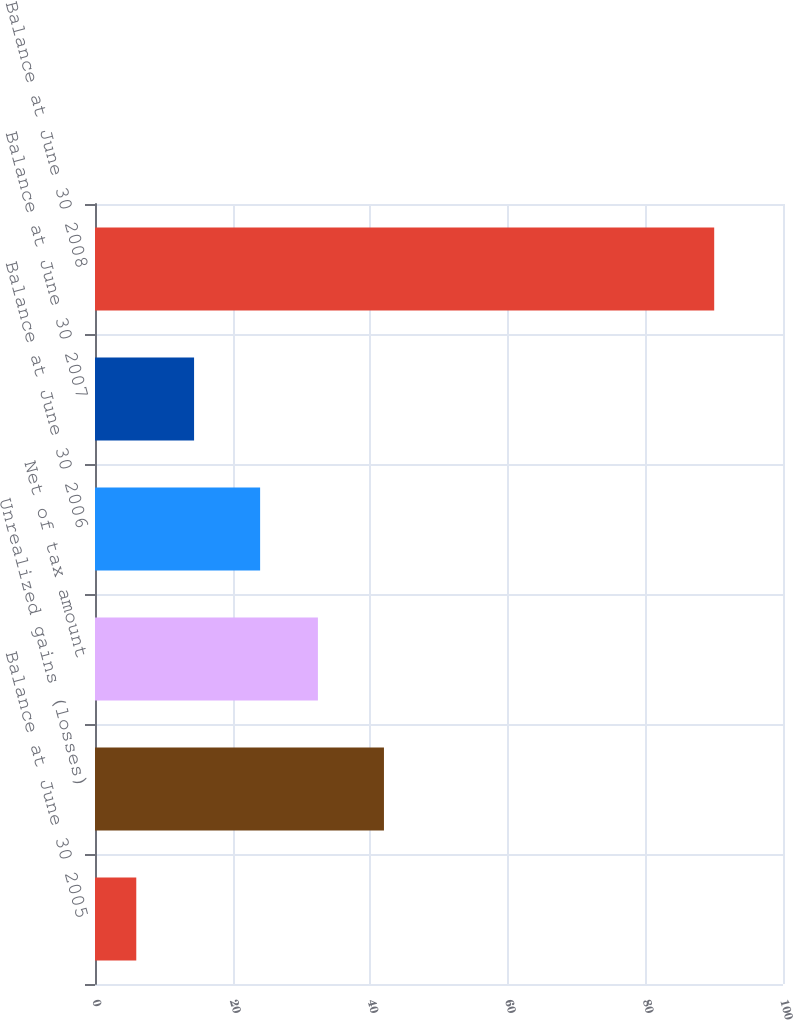<chart> <loc_0><loc_0><loc_500><loc_500><bar_chart><fcel>Balance at June 30 2005<fcel>Unrealized gains (losses)<fcel>Net of tax amount<fcel>Balance at June 30 2006<fcel>Balance at June 30 2007<fcel>Balance at June 30 2008<nl><fcel>6<fcel>42<fcel>32.4<fcel>24<fcel>14.4<fcel>90<nl></chart> 